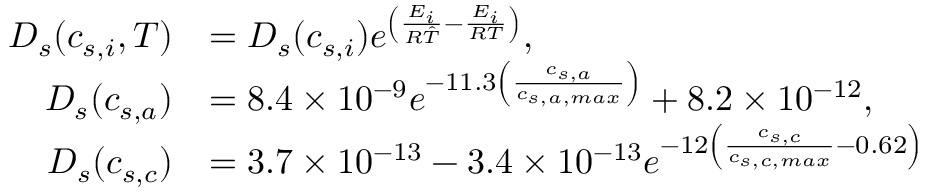<formula> <loc_0><loc_0><loc_500><loc_500>\begin{array} { r l } { D _ { s } ( c _ { s , i } , T ) } & { = D _ { s } ( c _ { s , i } ) e ^ { \left ( \frac { E _ { i } } { R \hat { T } } - \frac { E _ { i } } { R T } \right ) } , } \\ { D _ { s } ( c _ { s , a } ) } & { = 8 . 4 \times 1 0 ^ { - 9 } e ^ { - 1 1 . 3 \left ( \frac { c _ { s , a } } { c _ { s , a , \max } } \right ) } + 8 . 2 \times 1 0 ^ { - 1 2 } , } \\ { D _ { s } ( c _ { s , c } ) } & { = 3 . 7 \times 1 0 ^ { - 1 3 } - 3 . 4 \times 1 0 ^ { - 1 3 } e ^ { - 1 2 \left ( \frac { c _ { s , c } } { c _ { s , c , \max } } - 0 . 6 2 \right ) } } \end{array}</formula> 